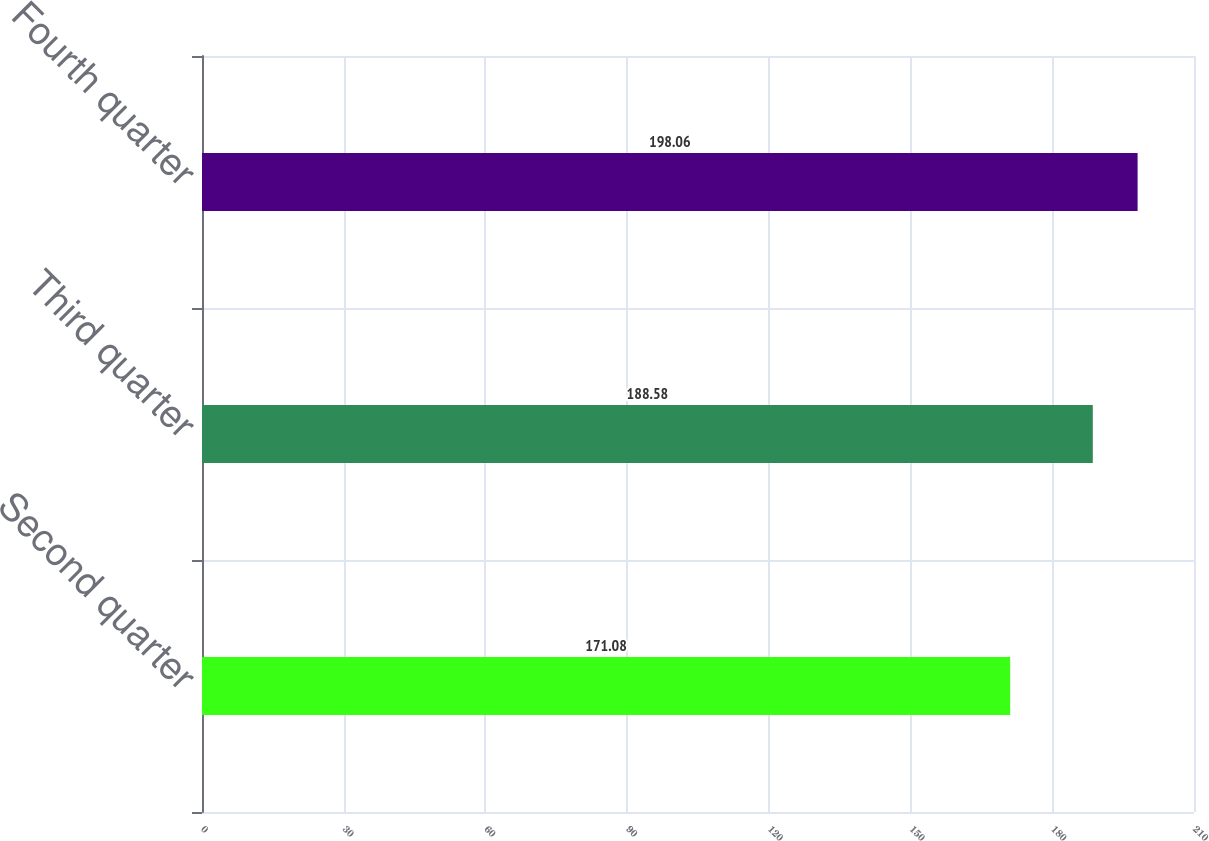Convert chart. <chart><loc_0><loc_0><loc_500><loc_500><bar_chart><fcel>Second quarter<fcel>Third quarter<fcel>Fourth quarter<nl><fcel>171.08<fcel>188.58<fcel>198.06<nl></chart> 